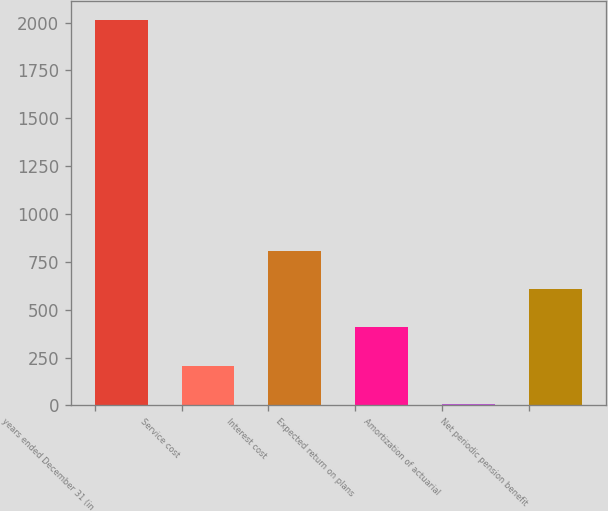Convert chart to OTSL. <chart><loc_0><loc_0><loc_500><loc_500><bar_chart><fcel>years ended December 31 (in<fcel>Service cost<fcel>Interest cost<fcel>Expected return on plans<fcel>Amortization of actuarial<fcel>Net periodic pension benefit<nl><fcel>2012<fcel>207.5<fcel>809<fcel>408<fcel>7<fcel>608.5<nl></chart> 